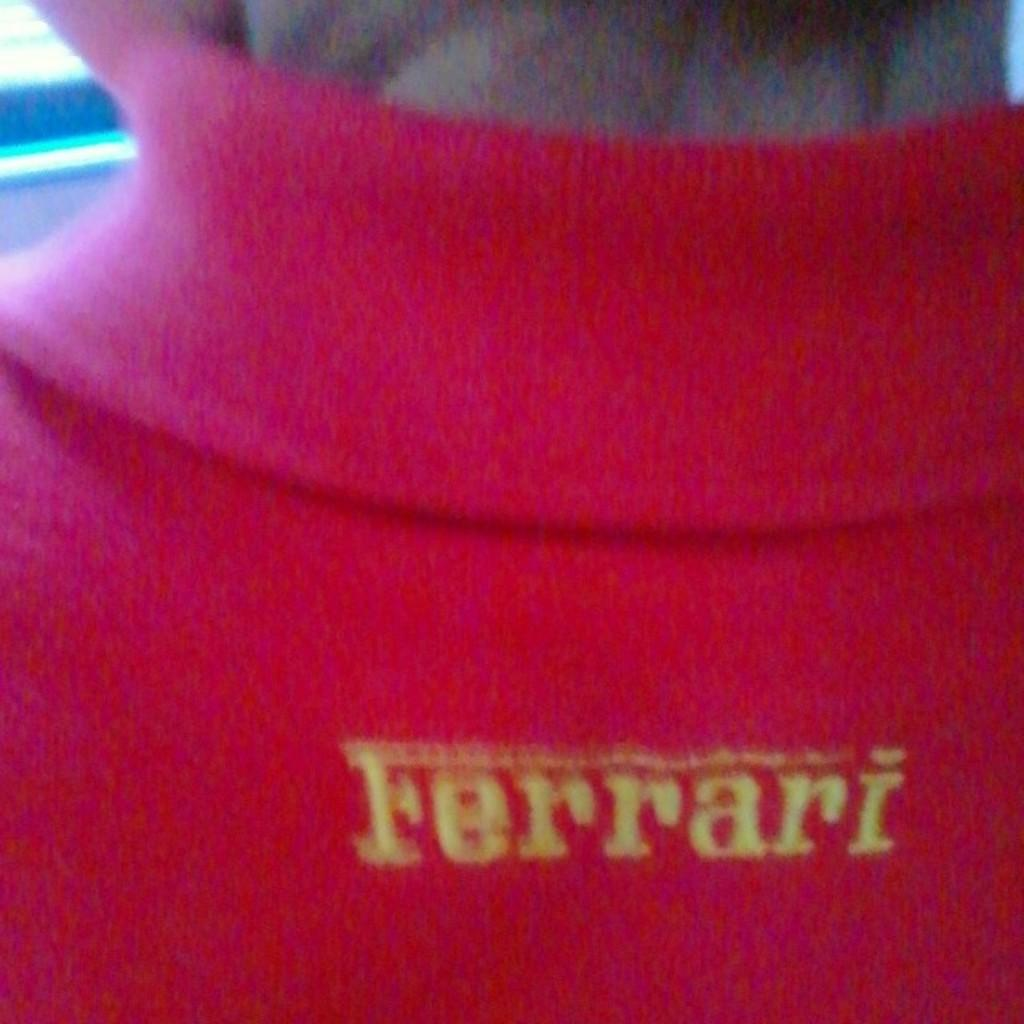What is present in the image? There is a person in the image. Can you describe the person's clothing? The person is wearing a red T-shirt. What type of cracker is the person holding in the image? There is no cracker present in the image. How many birds are visible in the image? There are no birds visible in the image. 